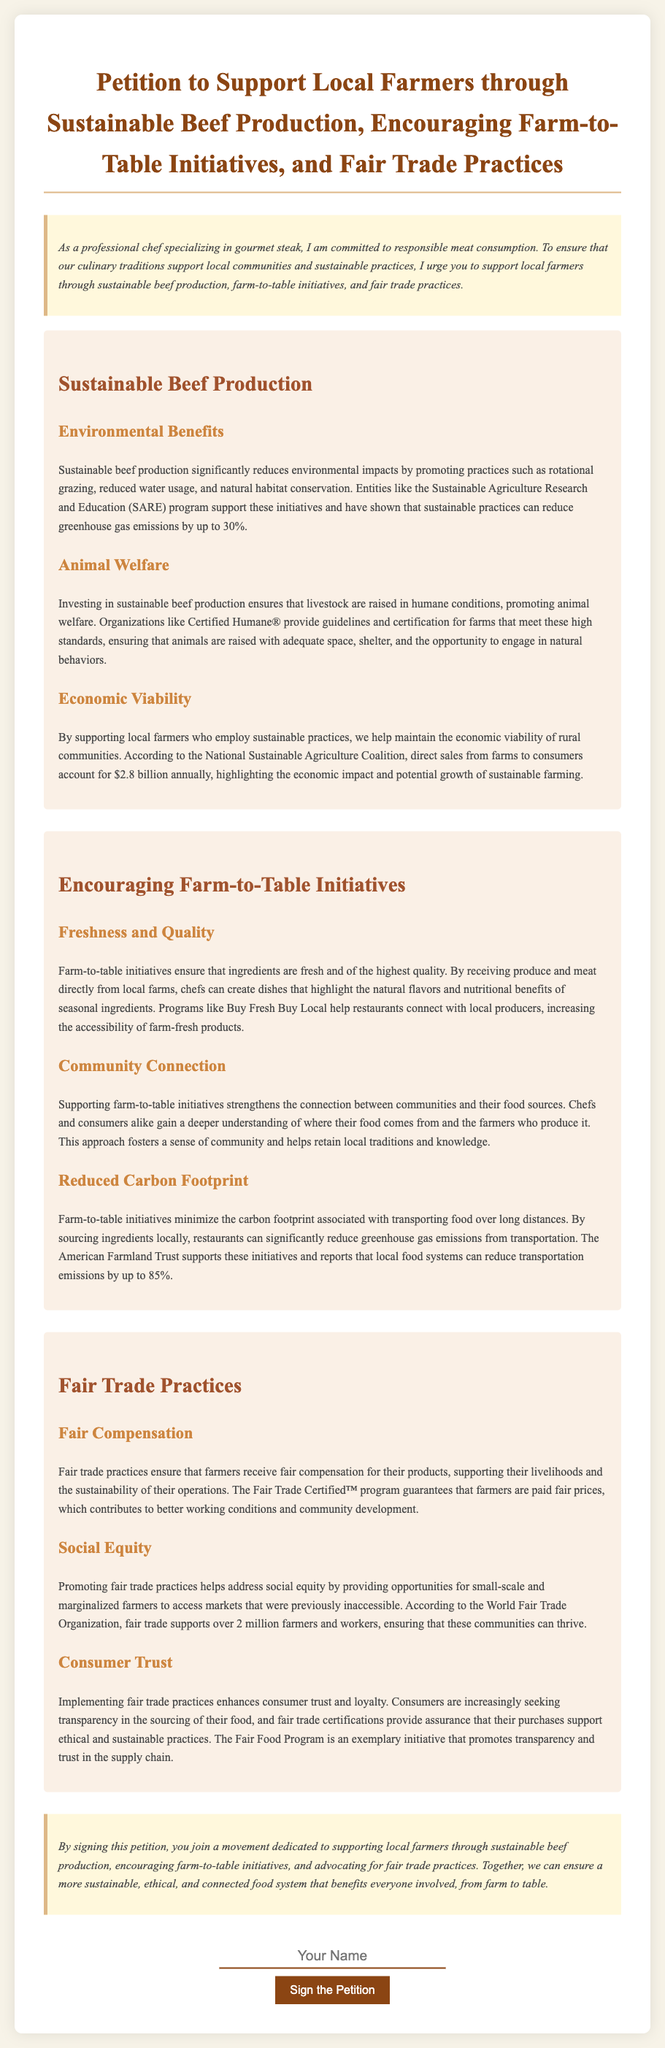What is the main purpose of the petition? The main purpose of the petition is to support local farmers through sustainable beef production, encouraging farm-to-table initiatives, and fair trade practices.
Answer: Support local farmers through sustainable beef production, encouraging farm-to-table initiatives, and fair trade practices Which organization supports sustainable practices that reduce greenhouse gas emissions? The document mentions the Sustainable Agriculture Research and Education (SARE) program as supporting sustainable practices that can reduce greenhouse gas emissions.
Answer: Sustainable Agriculture Research and Education (SARE) How much do direct sales from farms to consumers account for annually? The document states that direct sales from farms to consumers account for $2.8 billion annually.
Answer: $2.8 billion What is one animal welfare certification mentioned? The document references Certified Humane® as an organization that provides guidelines and certification for humane animal treatment.
Answer: Certified Humane® What is one benefit of farm-to-table initiatives according to the petition? The benefits mentioned include ensuring that ingredients are fresh and of the highest quality in farm-to-table initiatives.
Answer: Freshness and quality What percentage can local food systems reduce transportation emissions by? The document states that local food systems can reduce transportation emissions by up to 85%.
Answer: 85% What does fair trade ensure for farmers? Fair trade practices ensure that farmers receive fair compensation for their products.
Answer: Fair compensation According to the document, who supports over 2 million farmers and workers? The World Fair Trade Organization is mentioned as supporting over 2 million farmers and workers through fair trade practices.
Answer: World Fair Trade Organization What color is the petition text primarily? The primary color of the petition text is a shade of gray as stated in the style section of the document.
Answer: Gray 